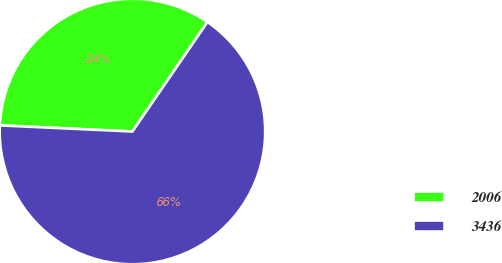Convert chart to OTSL. <chart><loc_0><loc_0><loc_500><loc_500><pie_chart><fcel>2006<fcel>3436<nl><fcel>33.83%<fcel>66.17%<nl></chart> 